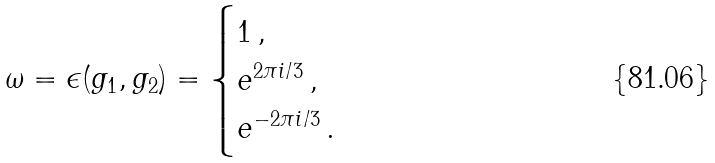Convert formula to latex. <formula><loc_0><loc_0><loc_500><loc_500>\omega = \epsilon ( g _ { 1 } , g _ { 2 } ) = \begin{cases} 1 \, , \\ e ^ { 2 \pi i / 3 } \, , \\ e ^ { - 2 \pi i / 3 } \, . \end{cases}</formula> 